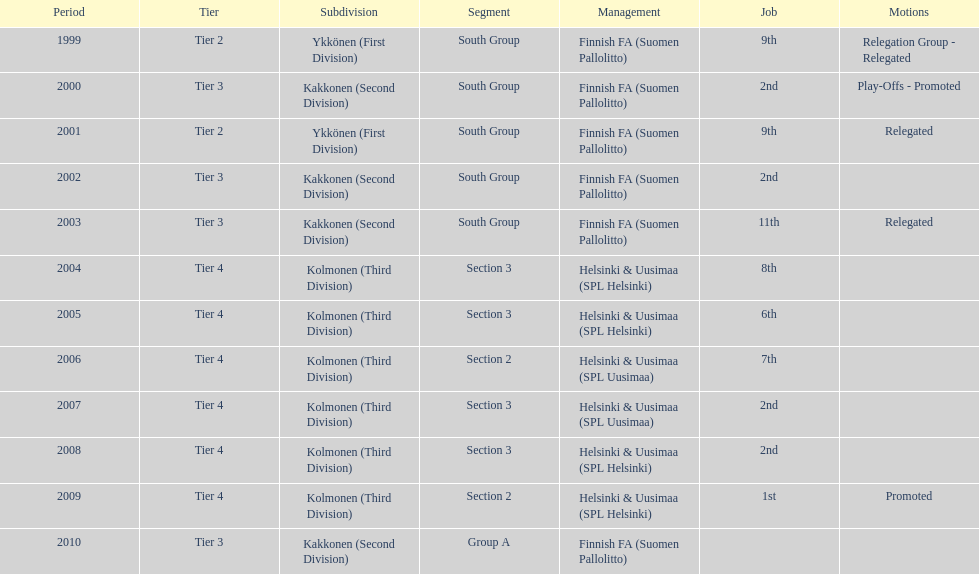What position did this team get after getting 9th place in 1999? 2nd. 